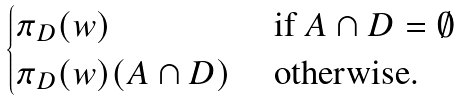Convert formula to latex. <formula><loc_0><loc_0><loc_500><loc_500>\begin{cases} \pi _ { D } ( w ) & \text { if } A \cap D = \emptyset \\ \pi _ { D } ( w ) ( A \cap D ) & \text { otherwise.} \end{cases}</formula> 